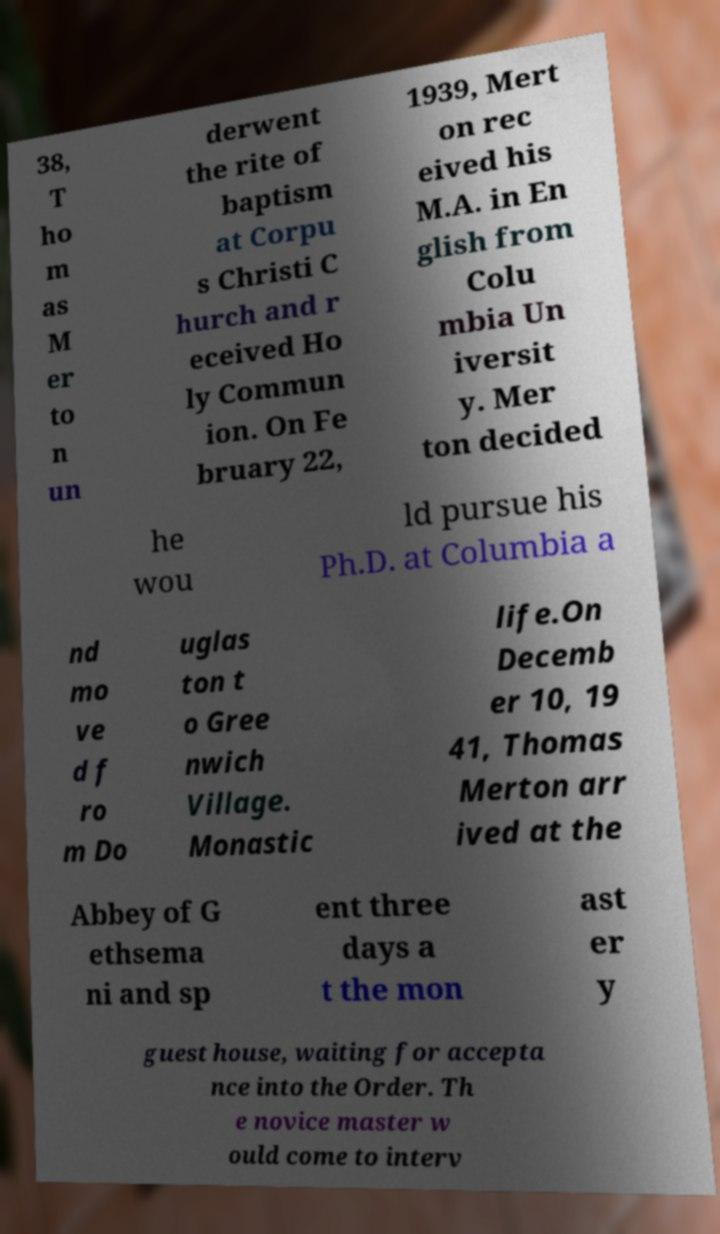Can you read and provide the text displayed in the image?This photo seems to have some interesting text. Can you extract and type it out for me? 38, T ho m as M er to n un derwent the rite of baptism at Corpu s Christi C hurch and r eceived Ho ly Commun ion. On Fe bruary 22, 1939, Mert on rec eived his M.A. in En glish from Colu mbia Un iversit y. Mer ton decided he wou ld pursue his Ph.D. at Columbia a nd mo ve d f ro m Do uglas ton t o Gree nwich Village. Monastic life.On Decemb er 10, 19 41, Thomas Merton arr ived at the Abbey of G ethsema ni and sp ent three days a t the mon ast er y guest house, waiting for accepta nce into the Order. Th e novice master w ould come to interv 